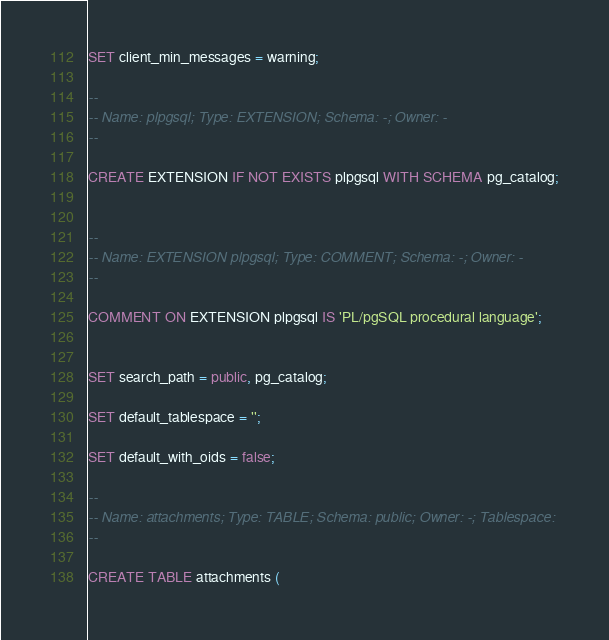Convert code to text. <code><loc_0><loc_0><loc_500><loc_500><_SQL_>SET client_min_messages = warning;

--
-- Name: plpgsql; Type: EXTENSION; Schema: -; Owner: -
--

CREATE EXTENSION IF NOT EXISTS plpgsql WITH SCHEMA pg_catalog;


--
-- Name: EXTENSION plpgsql; Type: COMMENT; Schema: -; Owner: -
--

COMMENT ON EXTENSION plpgsql IS 'PL/pgSQL procedural language';


SET search_path = public, pg_catalog;

SET default_tablespace = '';

SET default_with_oids = false;

--
-- Name: attachments; Type: TABLE; Schema: public; Owner: -; Tablespace: 
--

CREATE TABLE attachments (</code> 